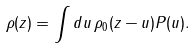<formula> <loc_0><loc_0><loc_500><loc_500>\rho ( z ) = \int d u \, \rho _ { 0 } ( z - u ) P ( u ) .</formula> 